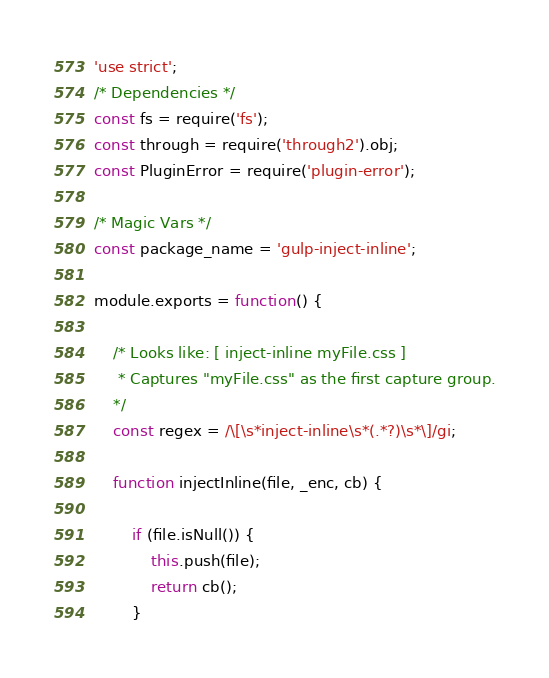<code> <loc_0><loc_0><loc_500><loc_500><_JavaScript_>'use strict';
/* Dependencies */
const fs = require('fs');
const through = require('through2').obj;
const PluginError = require('plugin-error');

/* Magic Vars */
const package_name = 'gulp-inject-inline';

module.exports = function() {

    /* Looks like: [ inject-inline myFile.css ]
     * Captures "myFile.css" as the first capture group.
    */
    const regex = /\[\s*inject-inline\s*(.*?)\s*\]/gi;

    function injectInline(file, _enc, cb) {

        if (file.isNull()) {
            this.push(file);
            return cb();
        }
</code> 